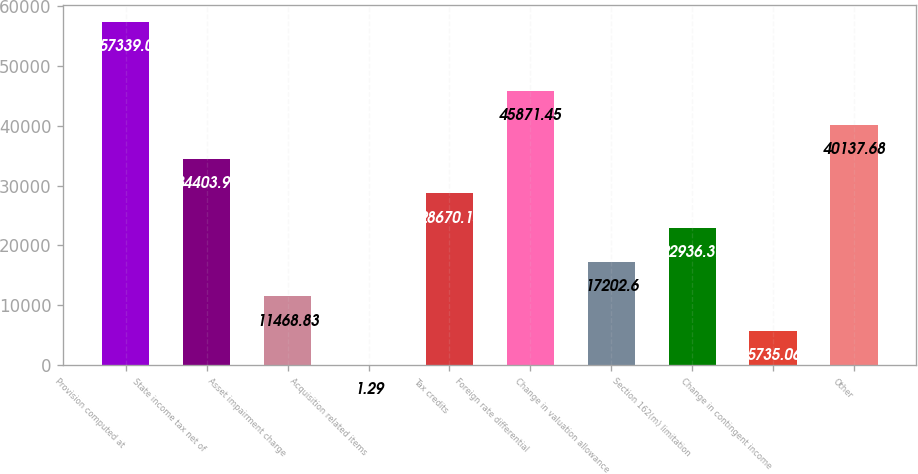<chart> <loc_0><loc_0><loc_500><loc_500><bar_chart><fcel>Provision computed at<fcel>State income tax net of<fcel>Asset impairment charge<fcel>Acquisition related items<fcel>Tax credits<fcel>Foreign rate differential<fcel>Change in valuation allowance<fcel>Section 162(m) limitation<fcel>Change in contingent income<fcel>Other<nl><fcel>57339<fcel>34403.9<fcel>11468.8<fcel>1.29<fcel>28670.1<fcel>45871.4<fcel>17202.6<fcel>22936.4<fcel>5735.06<fcel>40137.7<nl></chart> 